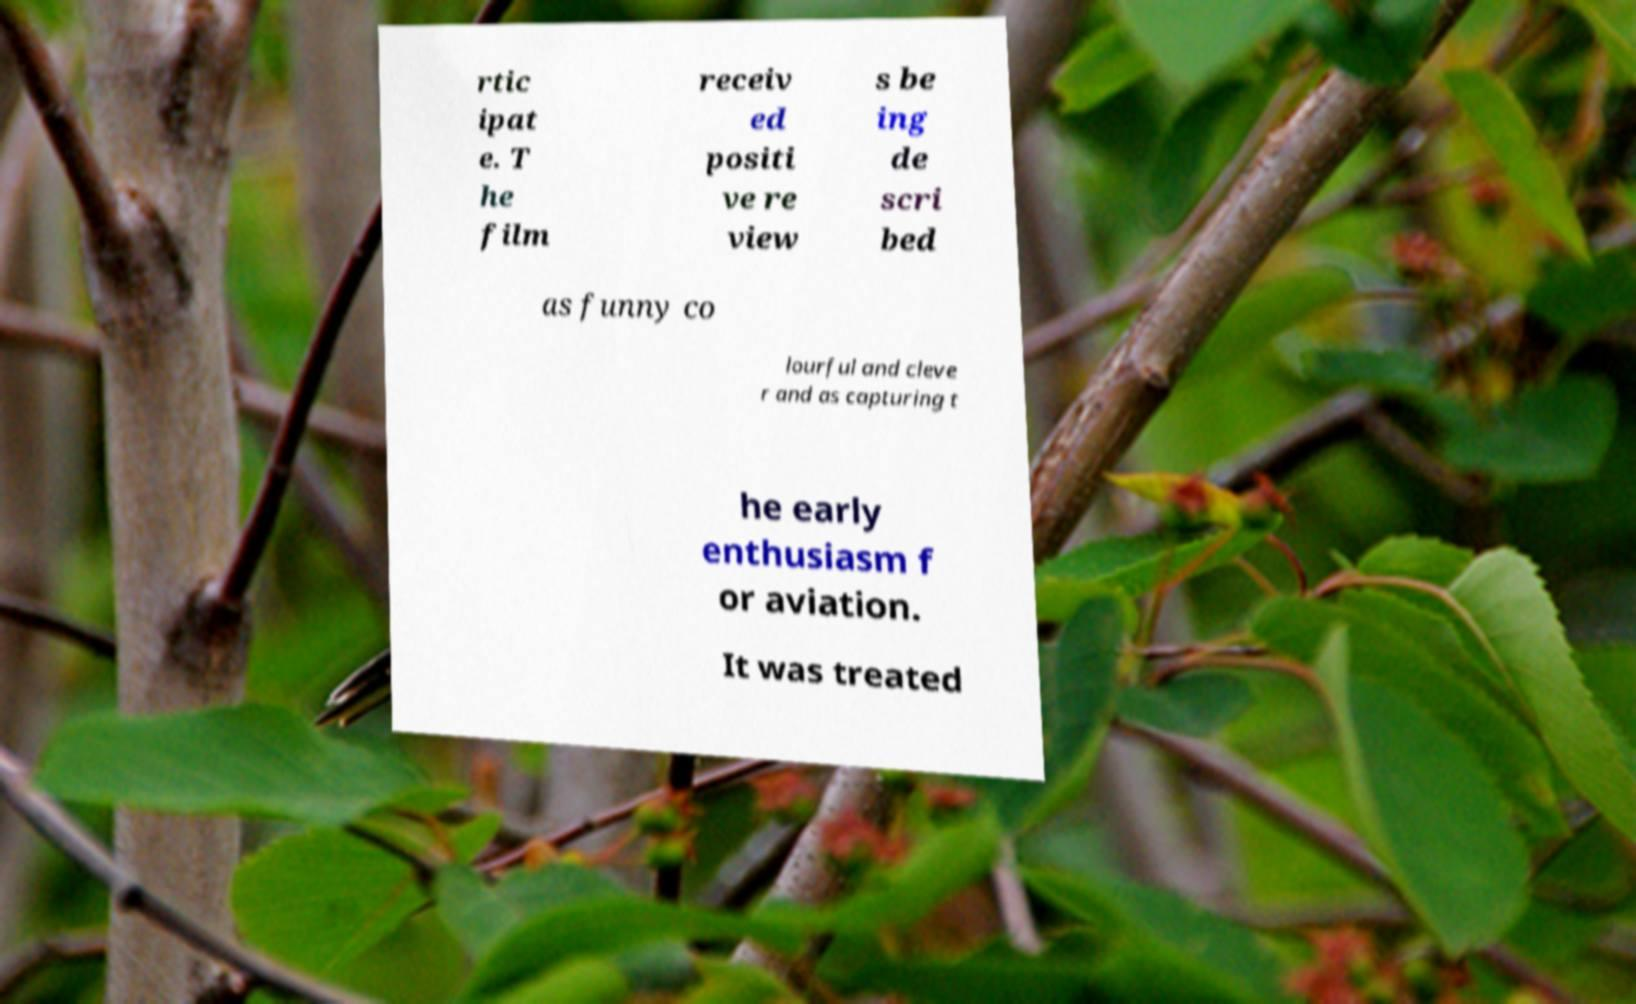For documentation purposes, I need the text within this image transcribed. Could you provide that? rtic ipat e. T he film receiv ed positi ve re view s be ing de scri bed as funny co lourful and cleve r and as capturing t he early enthusiasm f or aviation. It was treated 